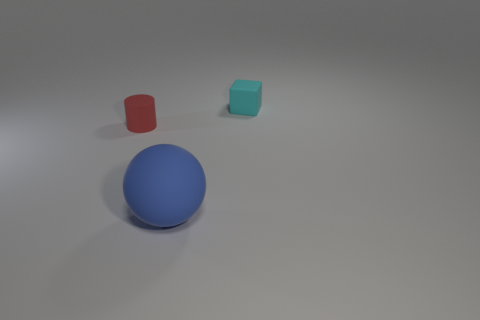What can you tell me about the lighting in this image? The lighting in the image seems to be diffused, with soft shadows being cast beneath the objects, indicating that the light source is not harsh or direct. This helps create a calm and evenly lit scene. 